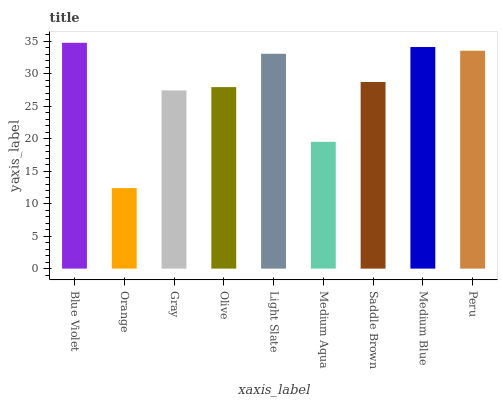Is Orange the minimum?
Answer yes or no. Yes. Is Blue Violet the maximum?
Answer yes or no. Yes. Is Gray the minimum?
Answer yes or no. No. Is Gray the maximum?
Answer yes or no. No. Is Gray greater than Orange?
Answer yes or no. Yes. Is Orange less than Gray?
Answer yes or no. Yes. Is Orange greater than Gray?
Answer yes or no. No. Is Gray less than Orange?
Answer yes or no. No. Is Saddle Brown the high median?
Answer yes or no. Yes. Is Saddle Brown the low median?
Answer yes or no. Yes. Is Orange the high median?
Answer yes or no. No. Is Light Slate the low median?
Answer yes or no. No. 